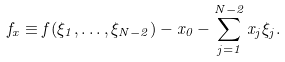Convert formula to latex. <formula><loc_0><loc_0><loc_500><loc_500>f _ { x } \equiv f ( \xi _ { 1 } , \dots , \xi _ { N - 2 } ) - x _ { 0 } - \sum _ { j = 1 } ^ { N - 2 } x _ { j } \xi _ { j } .</formula> 